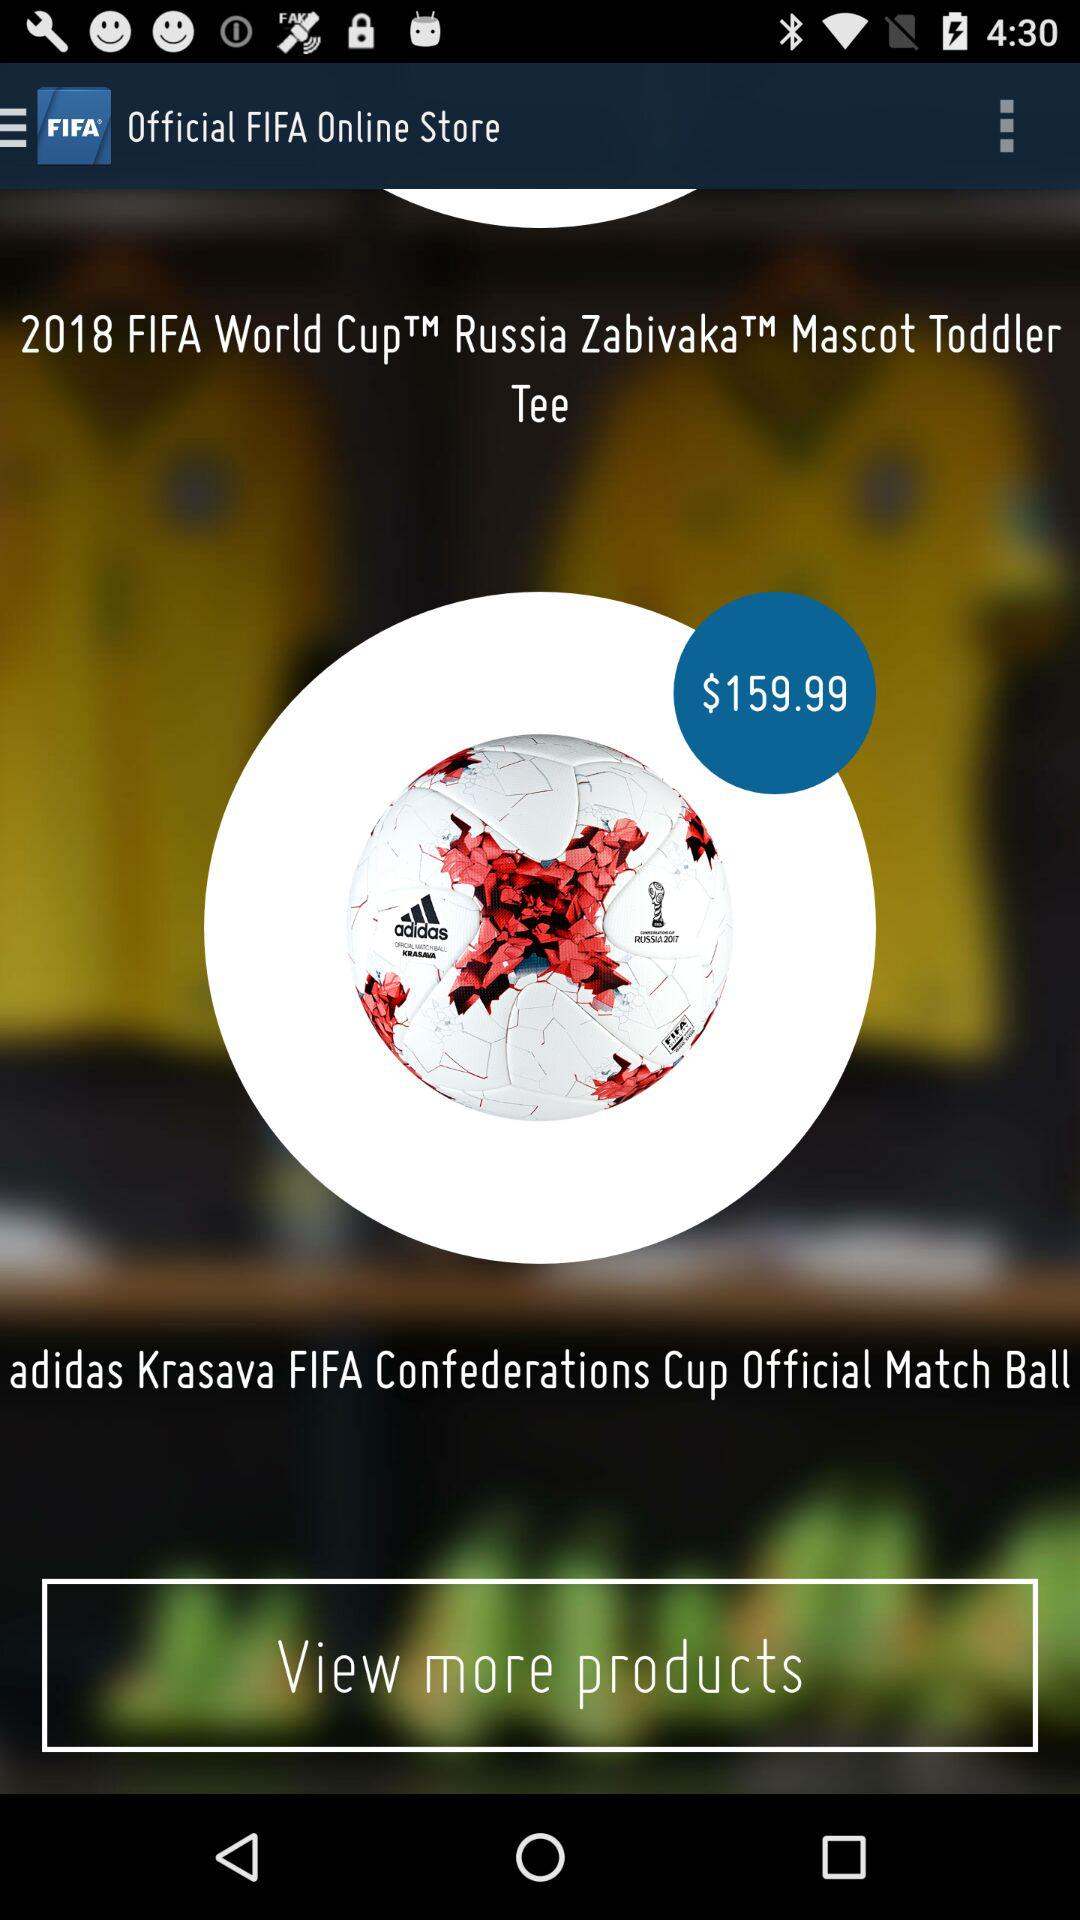What is the price of the match ball? The price is $159.99. 